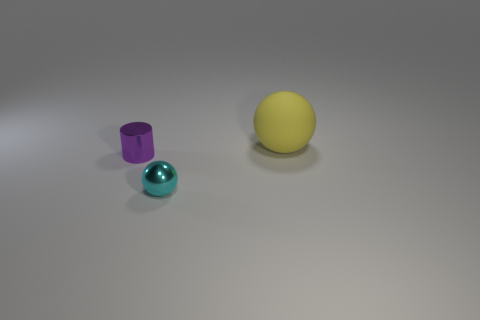Add 2 cyan spheres. How many objects exist? 5 Subtract all cylinders. How many objects are left? 2 Subtract 0 green cubes. How many objects are left? 3 Subtract all tiny red balls. Subtract all cyan things. How many objects are left? 2 Add 1 tiny cyan metallic things. How many tiny cyan metallic things are left? 2 Add 1 small yellow metallic cylinders. How many small yellow metallic cylinders exist? 1 